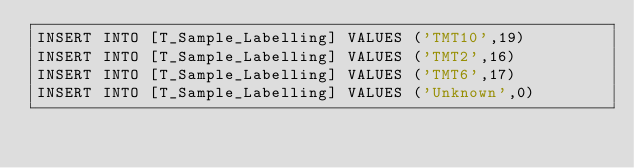Convert code to text. <code><loc_0><loc_0><loc_500><loc_500><_SQL_>INSERT INTO [T_Sample_Labelling] VALUES ('TMT10',19)
INSERT INTO [T_Sample_Labelling] VALUES ('TMT2',16)
INSERT INTO [T_Sample_Labelling] VALUES ('TMT6',17)
INSERT INTO [T_Sample_Labelling] VALUES ('Unknown',0)
</code> 